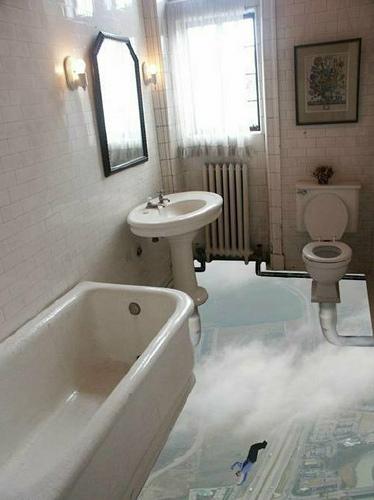Is the floor unfinished?
Give a very brief answer. Yes. Where is the bathroom floor?
Short answer required. Underwater. Has this picture been photoshopped?
Be succinct. Yes. 